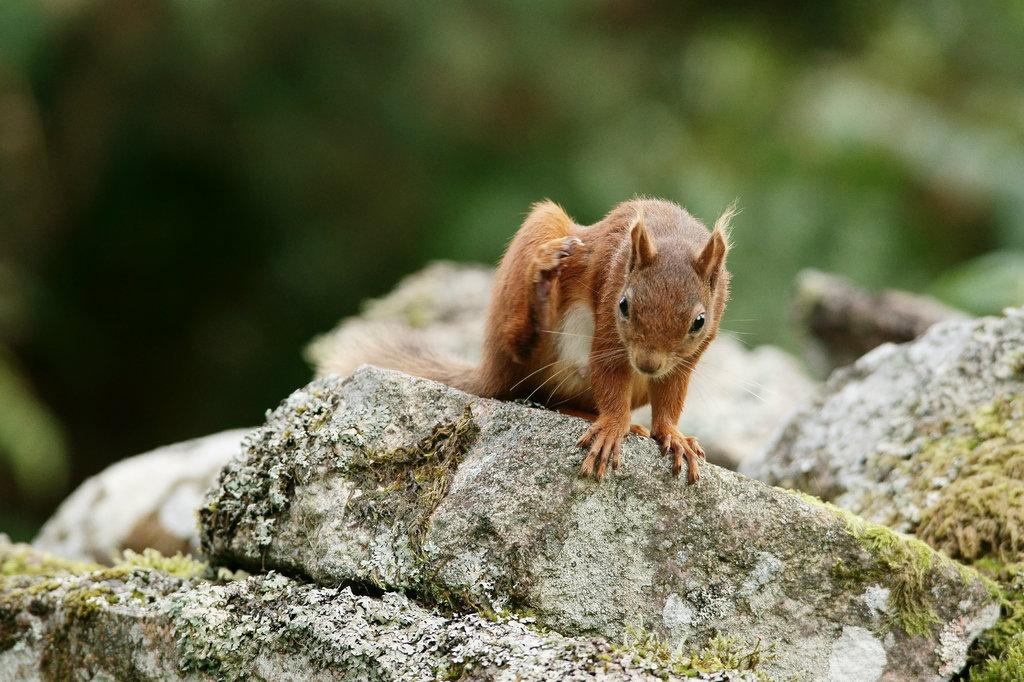What type of animal is in the image? There is a brown squirrel in the image. Where is the squirrel located? The squirrel is on a rock. What else can be seen in the image besides the squirrel? There are rocks in the image. Can you describe the background of the image? The background of the image is blurred. What color is the marble in the image? There is no marble present in the image. How many patches can be seen on the squirrel's ear in the image? The image does not show the squirrel's ear, so it is not possible to determine the number of patches on it. 